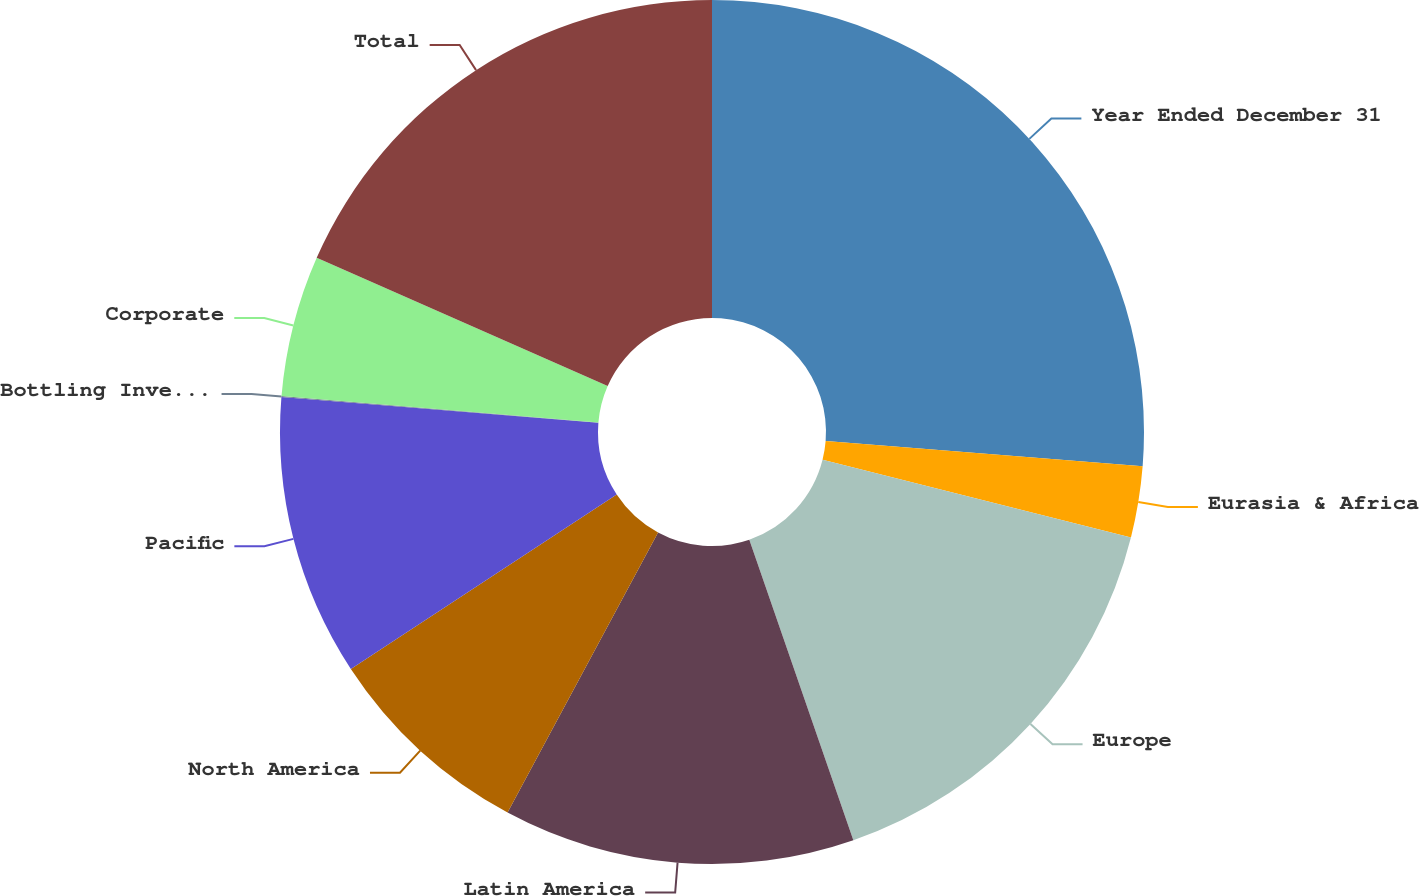<chart> <loc_0><loc_0><loc_500><loc_500><pie_chart><fcel>Year Ended December 31<fcel>Eurasia & Africa<fcel>Europe<fcel>Latin America<fcel>North America<fcel>Pacific<fcel>Bottling Investments<fcel>Corporate<fcel>Total<nl><fcel>26.26%<fcel>2.66%<fcel>15.77%<fcel>13.15%<fcel>7.91%<fcel>10.53%<fcel>0.04%<fcel>5.28%<fcel>18.39%<nl></chart> 